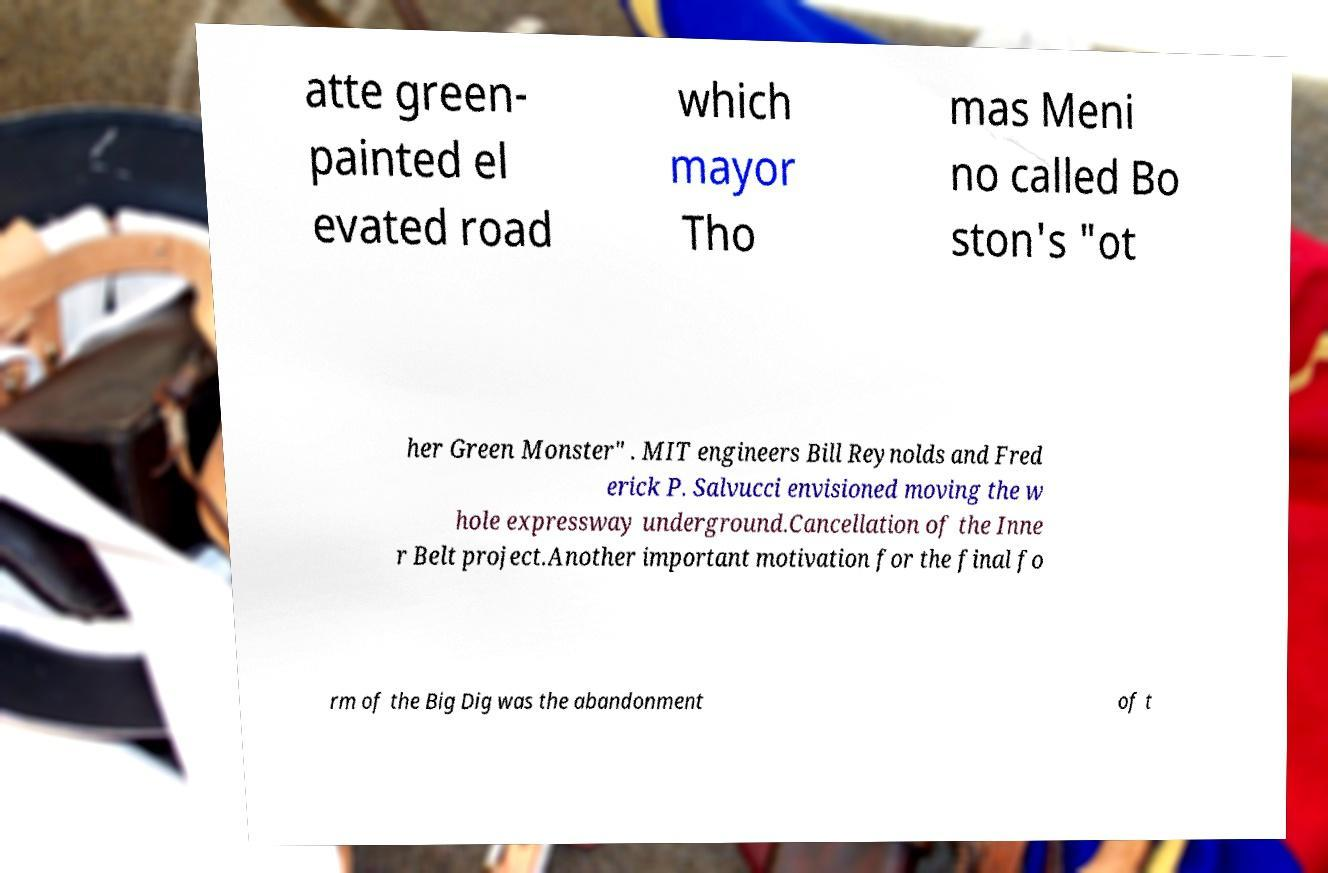For documentation purposes, I need the text within this image transcribed. Could you provide that? atte green- painted el evated road which mayor Tho mas Meni no called Bo ston's "ot her Green Monster" . MIT engineers Bill Reynolds and Fred erick P. Salvucci envisioned moving the w hole expressway underground.Cancellation of the Inne r Belt project.Another important motivation for the final fo rm of the Big Dig was the abandonment of t 